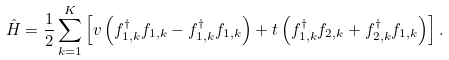<formula> <loc_0><loc_0><loc_500><loc_500>\hat { H } = \frac { 1 } { 2 } \sum _ { k = 1 } ^ { K } \left [ v \left ( f ^ { \dagger } _ { 1 , k } f _ { 1 , k } - f ^ { \dagger } _ { 1 , k } f _ { 1 , k } \right ) + t \left ( f ^ { \dagger } _ { 1 , k } f _ { 2 , k } + f ^ { \dagger } _ { 2 , k } f _ { 1 , k } \right ) \right ] .</formula> 